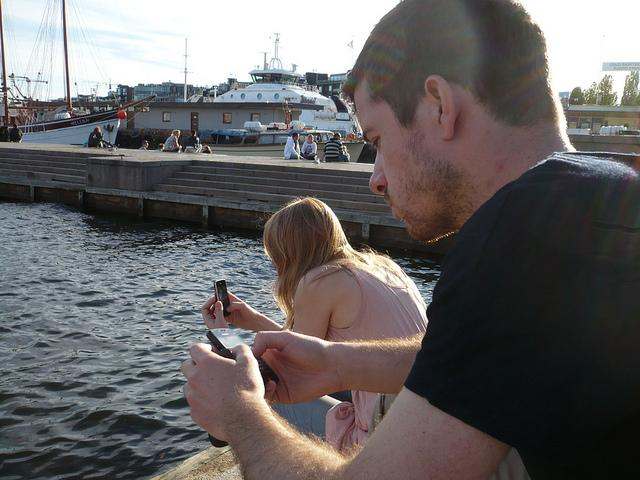If the man threw his phone 2 meters forward where would it land? water 